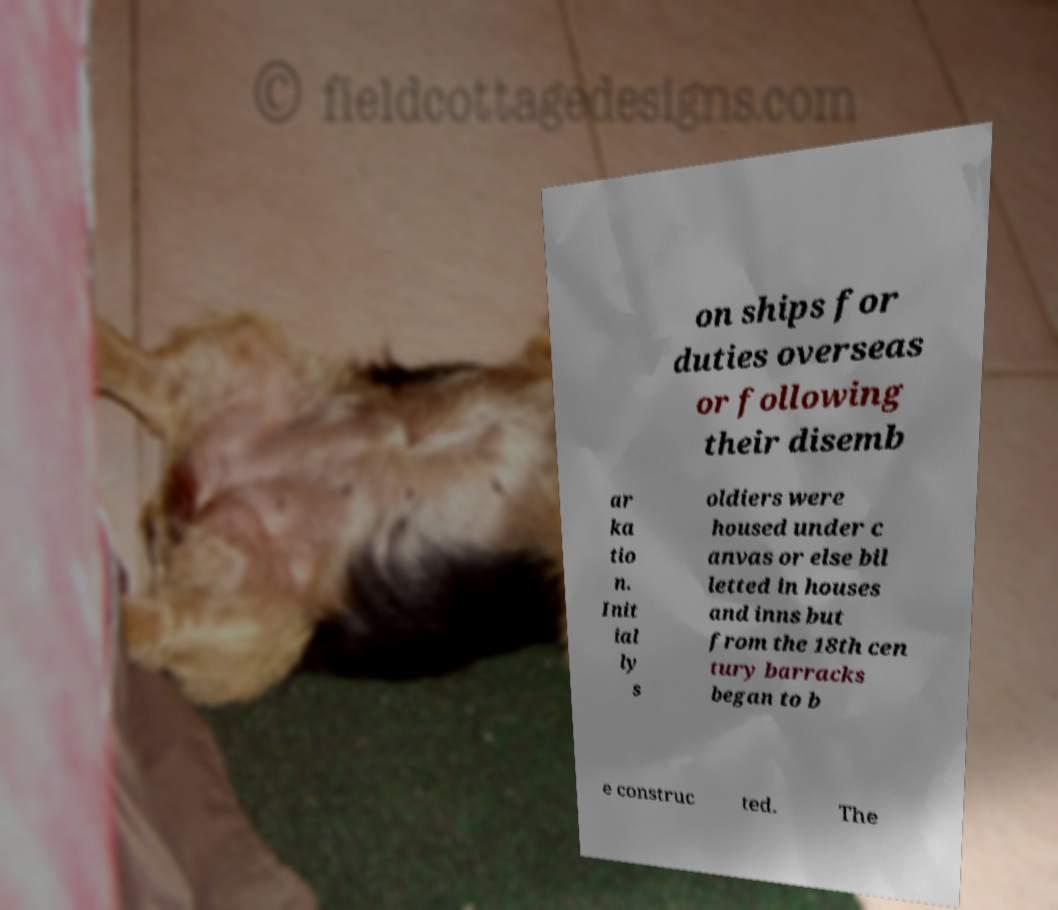Can you accurately transcribe the text from the provided image for me? on ships for duties overseas or following their disemb ar ka tio n. Init ial ly s oldiers were housed under c anvas or else bil letted in houses and inns but from the 18th cen tury barracks began to b e construc ted. The 